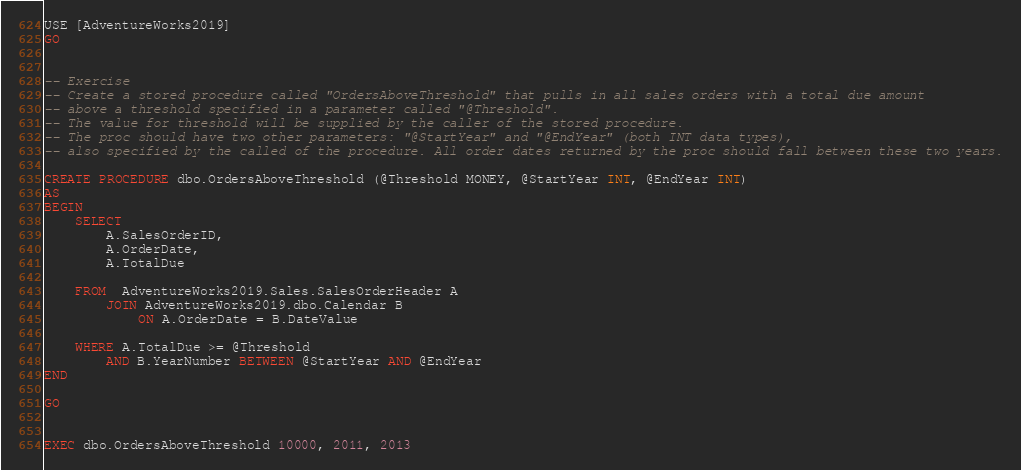Convert code to text. <code><loc_0><loc_0><loc_500><loc_500><_SQL_>USE [AdventureWorks2019]
GO


-- Exercise
-- Create a stored procedure called "OrdersAboveThreshold" that pulls in all sales orders with a total due amount
-- above a threshold specified in a parameter called "@Threshold".
-- The value for threshold will be supplied by the caller of the stored procedure.
-- The proc should have two other parameters: "@StartYear" and "@EndYear" (both INT data types),
-- also specified by the called of the procedure. All order dates returned by the proc should fall between these two years.

CREATE PROCEDURE dbo.OrdersAboveThreshold (@Threshold MONEY, @StartYear INT, @EndYear INT)
AS
BEGIN
	SELECT 
		A.SalesOrderID,
		A.OrderDate,
		A.TotalDue

	FROM  AdventureWorks2019.Sales.SalesOrderHeader A
		JOIN AdventureWorks2019.dbo.Calendar B
			ON A.OrderDate = B.DateValue

	WHERE A.TotalDue >= @Threshold
		AND B.YearNumber BETWEEN @StartYear AND @EndYear
END

GO


EXEC dbo.OrdersAboveThreshold 10000, 2011, 2013

</code> 